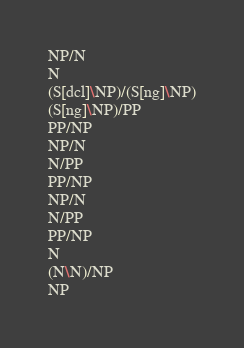<code> <loc_0><loc_0><loc_500><loc_500><_C_>NP/N
N
(S[dcl]\NP)/(S[ng]\NP)
(S[ng]\NP)/PP
PP/NP
NP/N
N/PP
PP/NP
NP/N
N/PP
PP/NP
N
(N\N)/NP
NP
</code> 